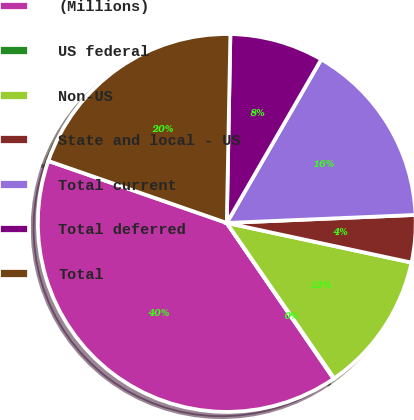<chart> <loc_0><loc_0><loc_500><loc_500><pie_chart><fcel>(Millions)<fcel>US federal<fcel>Non-US<fcel>State and local - US<fcel>Total current<fcel>Total deferred<fcel>Total<nl><fcel>39.89%<fcel>0.06%<fcel>12.01%<fcel>4.04%<fcel>15.99%<fcel>8.03%<fcel>19.98%<nl></chart> 